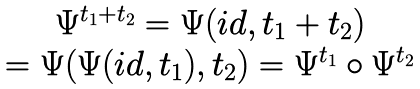<formula> <loc_0><loc_0><loc_500><loc_500>\begin{array} { c } \Psi ^ { t _ { 1 } + t _ { 2 } } = \Psi ( i d , t _ { 1 } + t _ { 2 } ) \\ = \Psi ( \Psi ( i d , t _ { 1 } ) , t _ { 2 } ) = \Psi ^ { t _ { 1 } } \circ \Psi ^ { t _ { 2 } } \end{array}</formula> 